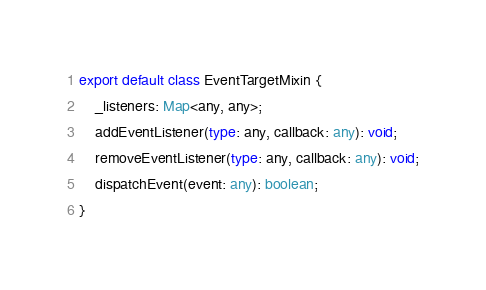Convert code to text. <code><loc_0><loc_0><loc_500><loc_500><_TypeScript_>export default class EventTargetMixin {
    _listeners: Map<any, any>;
    addEventListener(type: any, callback: any): void;
    removeEventListener(type: any, callback: any): void;
    dispatchEvent(event: any): boolean;
}
</code> 